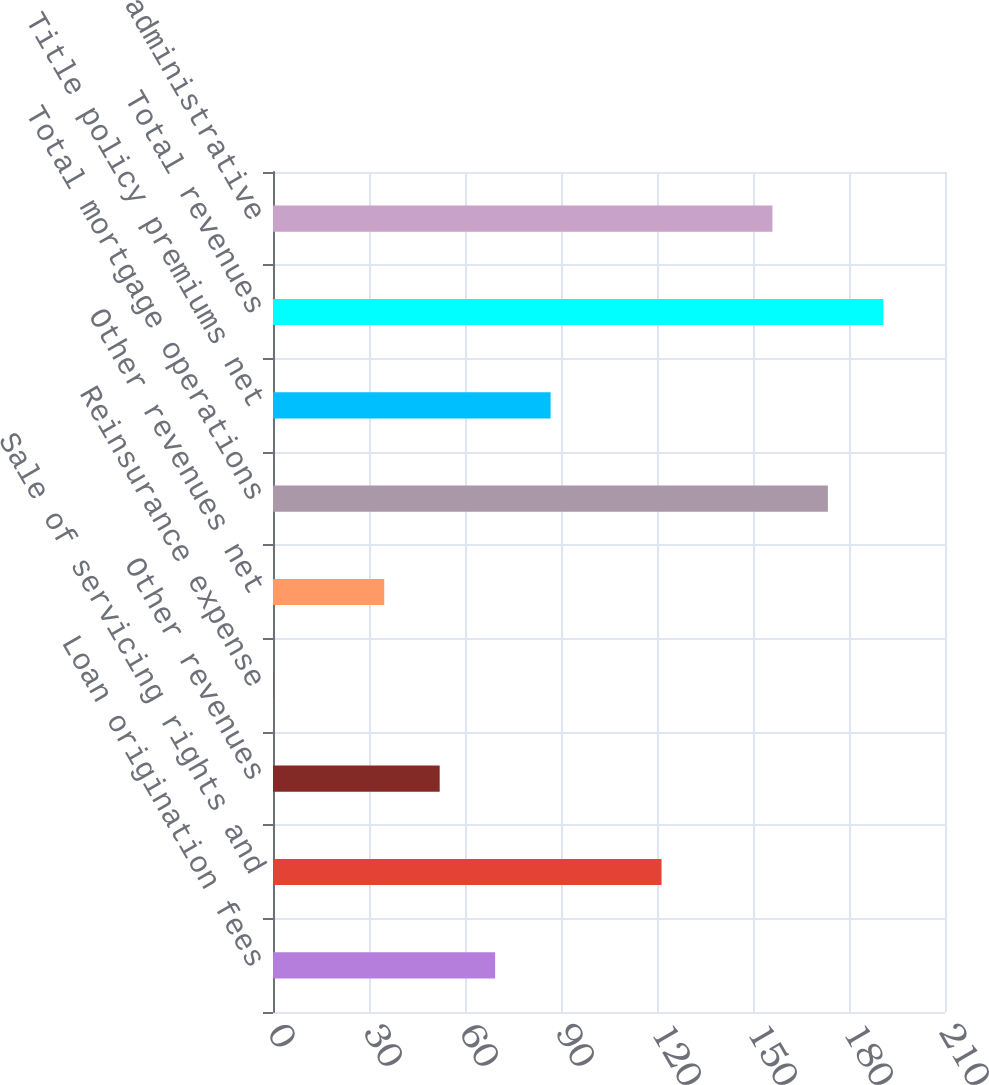Convert chart. <chart><loc_0><loc_0><loc_500><loc_500><bar_chart><fcel>Loan origination fees<fcel>Sale of servicing rights and<fcel>Other revenues<fcel>Reinsurance expense<fcel>Other revenues net<fcel>Total mortgage operations<fcel>Title policy premiums net<fcel>Total revenues<fcel>General and administrative<nl><fcel>69.42<fcel>121.41<fcel>52.09<fcel>0.1<fcel>34.76<fcel>173.4<fcel>86.75<fcel>190.73<fcel>156.07<nl></chart> 